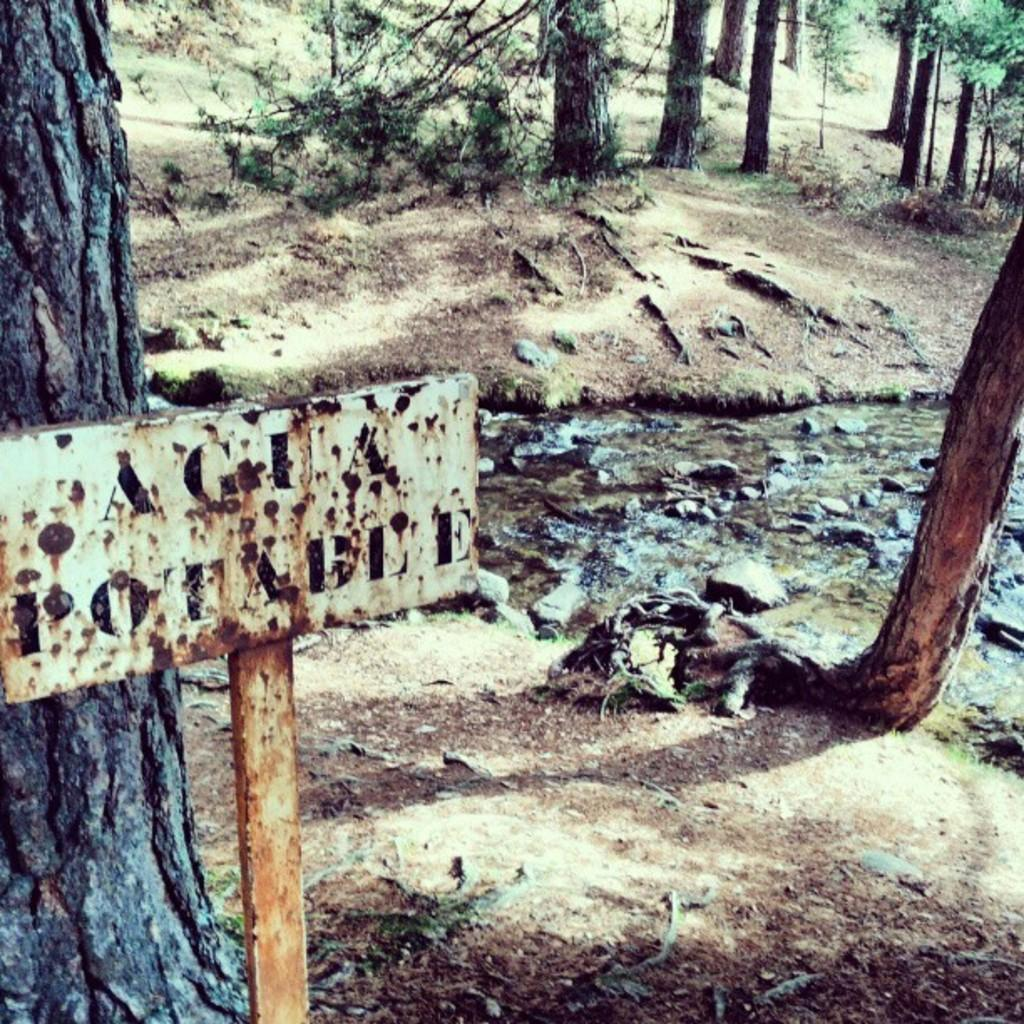What is the main object in the image with text on it? There is a board with text in the image. Where is the board located in the image? The board is in the front of the image. What can be seen on the ground in the image? There are stones on the ground in the image. What type of natural scenery is visible in the background of the image? There are trees in the background of the image. What type of furniture is visible in the image? There is no furniture present in the image. Is there a body of water visible in the image? No, there is no body of water visible in the image. 